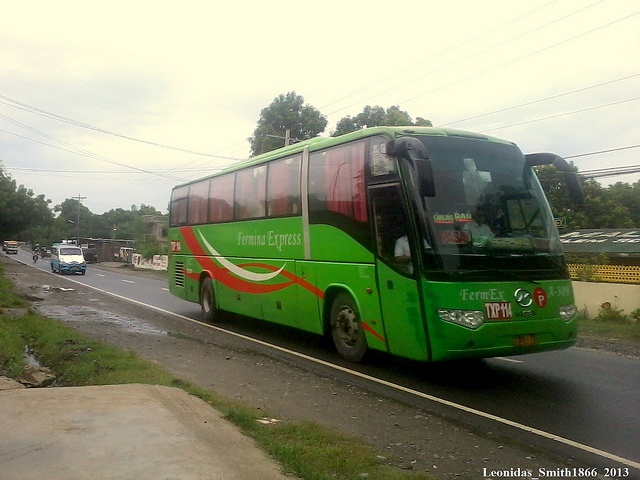Describe the objects in this image and their specific colors. I can see bus in lightyellow, black, darkgreen, gray, and darkgray tones, truck in lightyellow, gray, beige, darkgray, and black tones, car in lightyellow, gray, and black tones, truck in lightyellow, gray, black, darkgray, and tan tones, and motorcycle in lightyellow, gray, black, and darkgray tones in this image. 